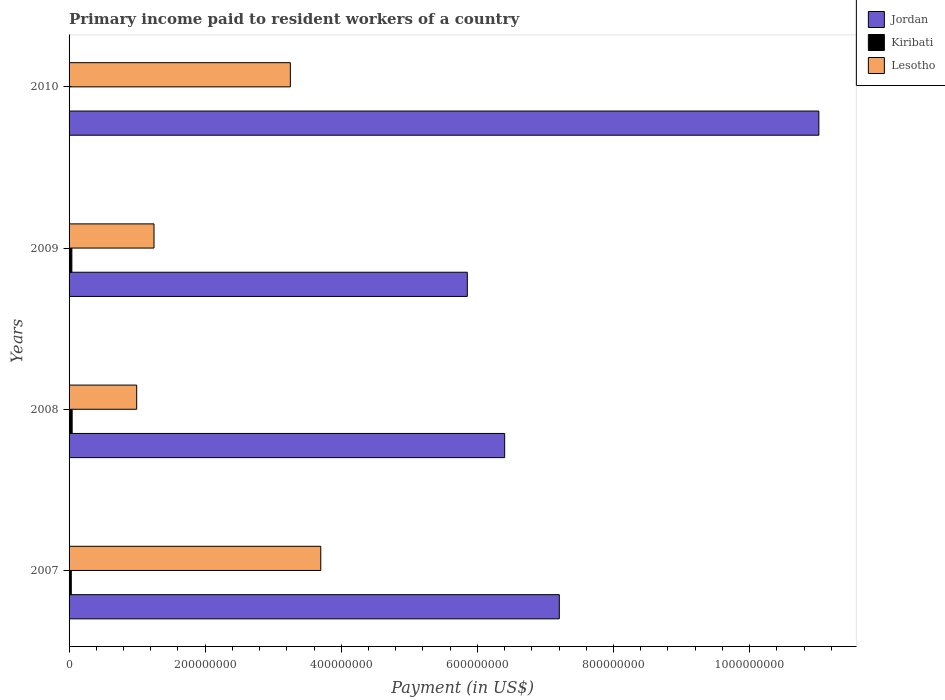How many groups of bars are there?
Offer a very short reply. 4. Are the number of bars on each tick of the Y-axis equal?
Offer a terse response. No. How many bars are there on the 2nd tick from the bottom?
Make the answer very short. 3. In how many cases, is the number of bars for a given year not equal to the number of legend labels?
Ensure brevity in your answer.  1. What is the amount paid to workers in Kiribati in 2007?
Give a very brief answer. 3.27e+06. Across all years, what is the maximum amount paid to workers in Kiribati?
Your answer should be compact. 4.54e+06. Across all years, what is the minimum amount paid to workers in Lesotho?
Provide a succinct answer. 9.93e+07. In which year was the amount paid to workers in Kiribati maximum?
Provide a short and direct response. 2008. What is the total amount paid to workers in Jordan in the graph?
Ensure brevity in your answer.  3.05e+09. What is the difference between the amount paid to workers in Jordan in 2009 and that in 2010?
Make the answer very short. -5.17e+08. What is the difference between the amount paid to workers in Kiribati in 2010 and the amount paid to workers in Lesotho in 2007?
Ensure brevity in your answer.  -3.70e+08. What is the average amount paid to workers in Lesotho per year?
Your response must be concise. 2.30e+08. In the year 2007, what is the difference between the amount paid to workers in Jordan and amount paid to workers in Lesotho?
Ensure brevity in your answer.  3.51e+08. In how many years, is the amount paid to workers in Jordan greater than 160000000 US$?
Keep it short and to the point. 4. What is the ratio of the amount paid to workers in Lesotho in 2007 to that in 2009?
Keep it short and to the point. 2.96. Is the amount paid to workers in Lesotho in 2009 less than that in 2010?
Your response must be concise. Yes. What is the difference between the highest and the second highest amount paid to workers in Lesotho?
Provide a succinct answer. 4.47e+07. What is the difference between the highest and the lowest amount paid to workers in Lesotho?
Ensure brevity in your answer.  2.70e+08. Is it the case that in every year, the sum of the amount paid to workers in Lesotho and amount paid to workers in Jordan is greater than the amount paid to workers in Kiribati?
Give a very brief answer. Yes. How many bars are there?
Give a very brief answer. 11. Are all the bars in the graph horizontal?
Give a very brief answer. Yes. What is the difference between two consecutive major ticks on the X-axis?
Ensure brevity in your answer.  2.00e+08. Are the values on the major ticks of X-axis written in scientific E-notation?
Give a very brief answer. No. Does the graph contain any zero values?
Provide a succinct answer. Yes. Does the graph contain grids?
Provide a succinct answer. No. How are the legend labels stacked?
Offer a very short reply. Vertical. What is the title of the graph?
Provide a short and direct response. Primary income paid to resident workers of a country. Does "Paraguay" appear as one of the legend labels in the graph?
Offer a very short reply. No. What is the label or title of the X-axis?
Your response must be concise. Payment (in US$). What is the label or title of the Y-axis?
Your response must be concise. Years. What is the Payment (in US$) in Jordan in 2007?
Offer a very short reply. 7.20e+08. What is the Payment (in US$) of Kiribati in 2007?
Make the answer very short. 3.27e+06. What is the Payment (in US$) of Lesotho in 2007?
Your answer should be compact. 3.70e+08. What is the Payment (in US$) of Jordan in 2008?
Your answer should be compact. 6.40e+08. What is the Payment (in US$) of Kiribati in 2008?
Offer a very short reply. 4.54e+06. What is the Payment (in US$) in Lesotho in 2008?
Your response must be concise. 9.93e+07. What is the Payment (in US$) of Jordan in 2009?
Your response must be concise. 5.85e+08. What is the Payment (in US$) of Kiribati in 2009?
Your response must be concise. 4.10e+06. What is the Payment (in US$) in Lesotho in 2009?
Your answer should be very brief. 1.25e+08. What is the Payment (in US$) in Jordan in 2010?
Offer a terse response. 1.10e+09. What is the Payment (in US$) of Lesotho in 2010?
Offer a terse response. 3.25e+08. Across all years, what is the maximum Payment (in US$) in Jordan?
Ensure brevity in your answer.  1.10e+09. Across all years, what is the maximum Payment (in US$) of Kiribati?
Your answer should be compact. 4.54e+06. Across all years, what is the maximum Payment (in US$) of Lesotho?
Make the answer very short. 3.70e+08. Across all years, what is the minimum Payment (in US$) of Jordan?
Make the answer very short. 5.85e+08. Across all years, what is the minimum Payment (in US$) in Kiribati?
Ensure brevity in your answer.  0. Across all years, what is the minimum Payment (in US$) in Lesotho?
Keep it short and to the point. 9.93e+07. What is the total Payment (in US$) of Jordan in the graph?
Offer a terse response. 3.05e+09. What is the total Payment (in US$) of Kiribati in the graph?
Offer a very short reply. 1.19e+07. What is the total Payment (in US$) in Lesotho in the graph?
Make the answer very short. 9.19e+08. What is the difference between the Payment (in US$) of Jordan in 2007 and that in 2008?
Ensure brevity in your answer.  8.03e+07. What is the difference between the Payment (in US$) of Kiribati in 2007 and that in 2008?
Your response must be concise. -1.27e+06. What is the difference between the Payment (in US$) of Lesotho in 2007 and that in 2008?
Your response must be concise. 2.70e+08. What is the difference between the Payment (in US$) of Jordan in 2007 and that in 2009?
Offer a very short reply. 1.35e+08. What is the difference between the Payment (in US$) in Kiribati in 2007 and that in 2009?
Ensure brevity in your answer.  -8.27e+05. What is the difference between the Payment (in US$) of Lesotho in 2007 and that in 2009?
Offer a terse response. 2.45e+08. What is the difference between the Payment (in US$) of Jordan in 2007 and that in 2010?
Your answer should be very brief. -3.81e+08. What is the difference between the Payment (in US$) in Lesotho in 2007 and that in 2010?
Offer a terse response. 4.47e+07. What is the difference between the Payment (in US$) in Jordan in 2008 and that in 2009?
Keep it short and to the point. 5.49e+07. What is the difference between the Payment (in US$) in Kiribati in 2008 and that in 2009?
Your answer should be very brief. 4.46e+05. What is the difference between the Payment (in US$) of Lesotho in 2008 and that in 2009?
Offer a very short reply. -2.55e+07. What is the difference between the Payment (in US$) of Jordan in 2008 and that in 2010?
Make the answer very short. -4.62e+08. What is the difference between the Payment (in US$) of Lesotho in 2008 and that in 2010?
Provide a short and direct response. -2.26e+08. What is the difference between the Payment (in US$) in Jordan in 2009 and that in 2010?
Provide a short and direct response. -5.17e+08. What is the difference between the Payment (in US$) of Lesotho in 2009 and that in 2010?
Provide a succinct answer. -2.00e+08. What is the difference between the Payment (in US$) in Jordan in 2007 and the Payment (in US$) in Kiribati in 2008?
Your response must be concise. 7.16e+08. What is the difference between the Payment (in US$) of Jordan in 2007 and the Payment (in US$) of Lesotho in 2008?
Offer a very short reply. 6.21e+08. What is the difference between the Payment (in US$) in Kiribati in 2007 and the Payment (in US$) in Lesotho in 2008?
Offer a terse response. -9.61e+07. What is the difference between the Payment (in US$) of Jordan in 2007 and the Payment (in US$) of Kiribati in 2009?
Ensure brevity in your answer.  7.16e+08. What is the difference between the Payment (in US$) in Jordan in 2007 and the Payment (in US$) in Lesotho in 2009?
Provide a short and direct response. 5.96e+08. What is the difference between the Payment (in US$) in Kiribati in 2007 and the Payment (in US$) in Lesotho in 2009?
Keep it short and to the point. -1.22e+08. What is the difference between the Payment (in US$) of Jordan in 2007 and the Payment (in US$) of Lesotho in 2010?
Provide a succinct answer. 3.95e+08. What is the difference between the Payment (in US$) in Kiribati in 2007 and the Payment (in US$) in Lesotho in 2010?
Your answer should be very brief. -3.22e+08. What is the difference between the Payment (in US$) of Jordan in 2008 and the Payment (in US$) of Kiribati in 2009?
Offer a terse response. 6.36e+08. What is the difference between the Payment (in US$) of Jordan in 2008 and the Payment (in US$) of Lesotho in 2009?
Your response must be concise. 5.15e+08. What is the difference between the Payment (in US$) in Kiribati in 2008 and the Payment (in US$) in Lesotho in 2009?
Provide a short and direct response. -1.20e+08. What is the difference between the Payment (in US$) in Jordan in 2008 and the Payment (in US$) in Lesotho in 2010?
Your response must be concise. 3.15e+08. What is the difference between the Payment (in US$) of Kiribati in 2008 and the Payment (in US$) of Lesotho in 2010?
Keep it short and to the point. -3.21e+08. What is the difference between the Payment (in US$) of Jordan in 2009 and the Payment (in US$) of Lesotho in 2010?
Make the answer very short. 2.60e+08. What is the difference between the Payment (in US$) in Kiribati in 2009 and the Payment (in US$) in Lesotho in 2010?
Give a very brief answer. -3.21e+08. What is the average Payment (in US$) in Jordan per year?
Your answer should be compact. 7.62e+08. What is the average Payment (in US$) in Kiribati per year?
Offer a terse response. 2.98e+06. What is the average Payment (in US$) in Lesotho per year?
Make the answer very short. 2.30e+08. In the year 2007, what is the difference between the Payment (in US$) in Jordan and Payment (in US$) in Kiribati?
Your response must be concise. 7.17e+08. In the year 2007, what is the difference between the Payment (in US$) in Jordan and Payment (in US$) in Lesotho?
Provide a succinct answer. 3.51e+08. In the year 2007, what is the difference between the Payment (in US$) in Kiribati and Payment (in US$) in Lesotho?
Offer a terse response. -3.67e+08. In the year 2008, what is the difference between the Payment (in US$) of Jordan and Payment (in US$) of Kiribati?
Give a very brief answer. 6.36e+08. In the year 2008, what is the difference between the Payment (in US$) in Jordan and Payment (in US$) in Lesotho?
Offer a terse response. 5.41e+08. In the year 2008, what is the difference between the Payment (in US$) in Kiribati and Payment (in US$) in Lesotho?
Offer a terse response. -9.48e+07. In the year 2009, what is the difference between the Payment (in US$) of Jordan and Payment (in US$) of Kiribati?
Offer a very short reply. 5.81e+08. In the year 2009, what is the difference between the Payment (in US$) of Jordan and Payment (in US$) of Lesotho?
Your answer should be compact. 4.60e+08. In the year 2009, what is the difference between the Payment (in US$) in Kiribati and Payment (in US$) in Lesotho?
Ensure brevity in your answer.  -1.21e+08. In the year 2010, what is the difference between the Payment (in US$) of Jordan and Payment (in US$) of Lesotho?
Offer a terse response. 7.77e+08. What is the ratio of the Payment (in US$) of Jordan in 2007 to that in 2008?
Provide a short and direct response. 1.13. What is the ratio of the Payment (in US$) of Kiribati in 2007 to that in 2008?
Give a very brief answer. 0.72. What is the ratio of the Payment (in US$) in Lesotho in 2007 to that in 2008?
Offer a terse response. 3.72. What is the ratio of the Payment (in US$) in Jordan in 2007 to that in 2009?
Keep it short and to the point. 1.23. What is the ratio of the Payment (in US$) of Kiribati in 2007 to that in 2009?
Provide a succinct answer. 0.8. What is the ratio of the Payment (in US$) of Lesotho in 2007 to that in 2009?
Make the answer very short. 2.96. What is the ratio of the Payment (in US$) of Jordan in 2007 to that in 2010?
Ensure brevity in your answer.  0.65. What is the ratio of the Payment (in US$) in Lesotho in 2007 to that in 2010?
Offer a very short reply. 1.14. What is the ratio of the Payment (in US$) of Jordan in 2008 to that in 2009?
Make the answer very short. 1.09. What is the ratio of the Payment (in US$) of Kiribati in 2008 to that in 2009?
Give a very brief answer. 1.11. What is the ratio of the Payment (in US$) in Lesotho in 2008 to that in 2009?
Keep it short and to the point. 0.8. What is the ratio of the Payment (in US$) of Jordan in 2008 to that in 2010?
Ensure brevity in your answer.  0.58. What is the ratio of the Payment (in US$) in Lesotho in 2008 to that in 2010?
Give a very brief answer. 0.31. What is the ratio of the Payment (in US$) of Jordan in 2009 to that in 2010?
Give a very brief answer. 0.53. What is the ratio of the Payment (in US$) of Lesotho in 2009 to that in 2010?
Ensure brevity in your answer.  0.38. What is the difference between the highest and the second highest Payment (in US$) in Jordan?
Your response must be concise. 3.81e+08. What is the difference between the highest and the second highest Payment (in US$) in Kiribati?
Make the answer very short. 4.46e+05. What is the difference between the highest and the second highest Payment (in US$) in Lesotho?
Make the answer very short. 4.47e+07. What is the difference between the highest and the lowest Payment (in US$) of Jordan?
Your answer should be compact. 5.17e+08. What is the difference between the highest and the lowest Payment (in US$) of Kiribati?
Your response must be concise. 4.54e+06. What is the difference between the highest and the lowest Payment (in US$) in Lesotho?
Make the answer very short. 2.70e+08. 